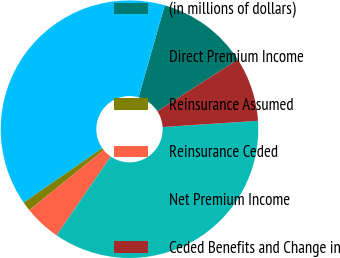Convert chart. <chart><loc_0><loc_0><loc_500><loc_500><pie_chart><fcel>(in millions of dollars)<fcel>Direct Premium Income<fcel>Reinsurance Assumed<fcel>Reinsurance Ceded<fcel>Net Premium Income<fcel>Ceded Benefits and Change in<nl><fcel>11.5%<fcel>39.07%<fcel>1.16%<fcel>4.6%<fcel>35.62%<fcel>8.05%<nl></chart> 